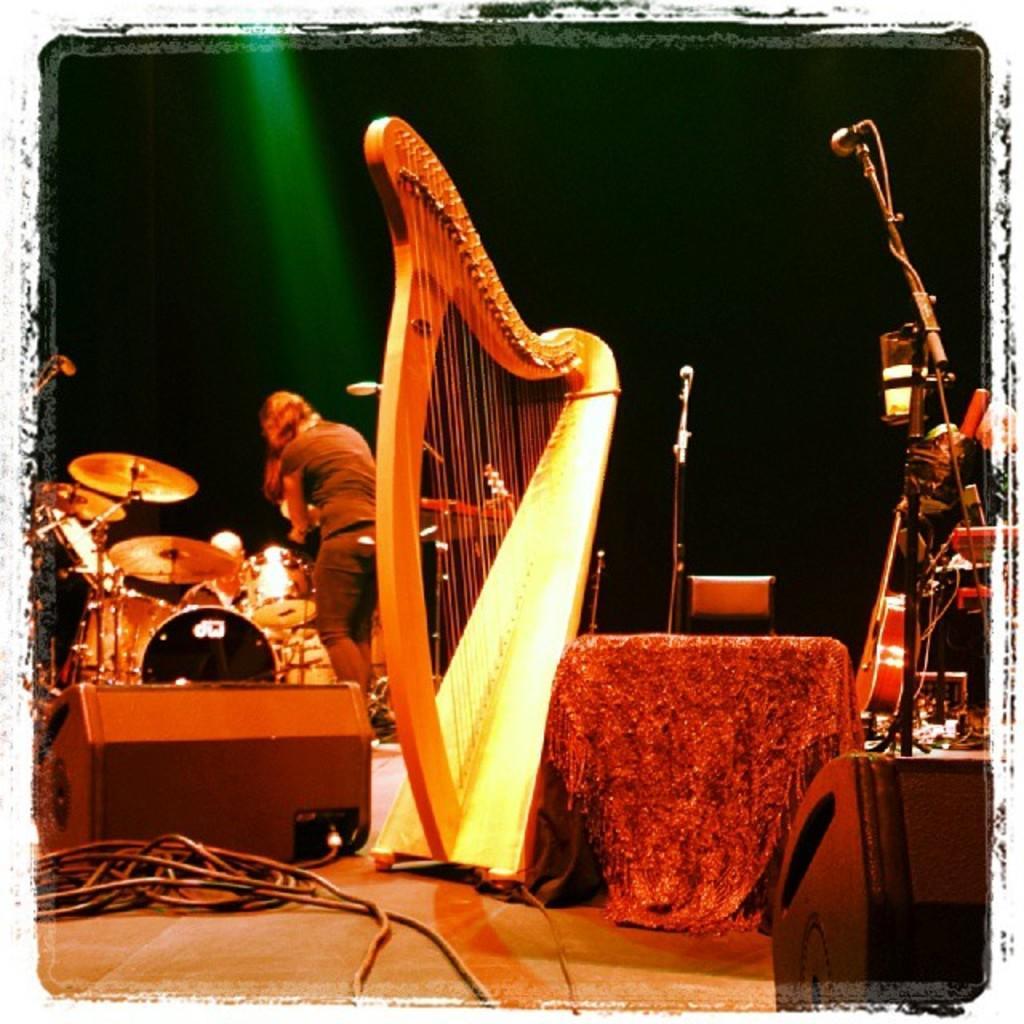Can you describe this image briefly? In this image there is a person on the stage with a musical instruments around. There is a mic and a stand. 